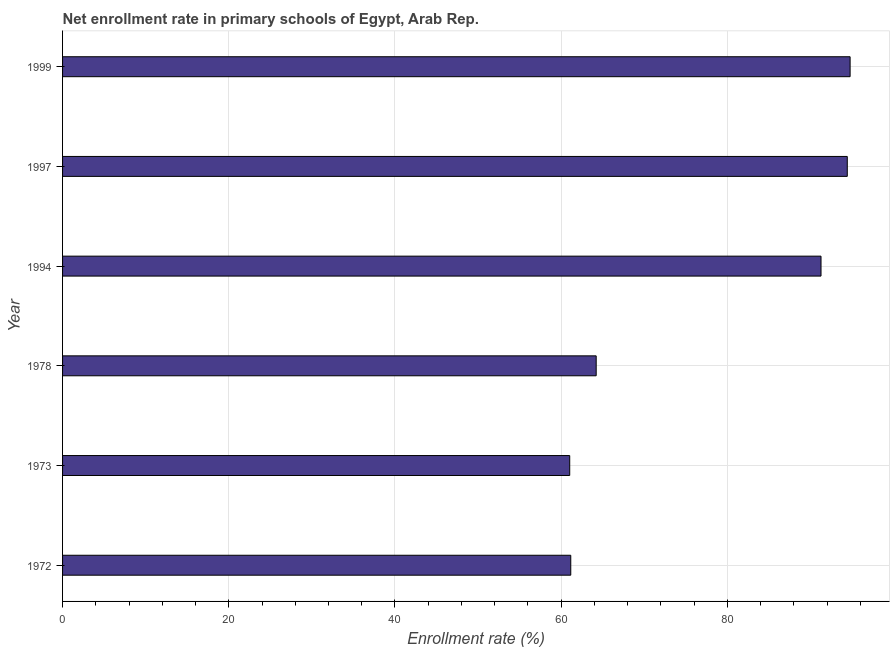Does the graph contain any zero values?
Provide a succinct answer. No. What is the title of the graph?
Give a very brief answer. Net enrollment rate in primary schools of Egypt, Arab Rep. What is the label or title of the X-axis?
Offer a terse response. Enrollment rate (%). What is the label or title of the Y-axis?
Your answer should be compact. Year. What is the net enrollment rate in primary schools in 1997?
Provide a short and direct response. 94.43. Across all years, what is the maximum net enrollment rate in primary schools?
Offer a terse response. 94.77. Across all years, what is the minimum net enrollment rate in primary schools?
Your answer should be very brief. 61.03. In which year was the net enrollment rate in primary schools maximum?
Provide a short and direct response. 1999. What is the sum of the net enrollment rate in primary schools?
Your answer should be compact. 466.87. What is the difference between the net enrollment rate in primary schools in 1978 and 1994?
Your answer should be compact. -27.06. What is the average net enrollment rate in primary schools per year?
Make the answer very short. 77.81. What is the median net enrollment rate in primary schools?
Your answer should be compact. 77.74. Do a majority of the years between 1999 and 1973 (inclusive) have net enrollment rate in primary schools greater than 40 %?
Make the answer very short. Yes. What is the ratio of the net enrollment rate in primary schools in 1978 to that in 1994?
Give a very brief answer. 0.7. Is the net enrollment rate in primary schools in 1973 less than that in 1997?
Provide a short and direct response. Yes. What is the difference between the highest and the second highest net enrollment rate in primary schools?
Provide a succinct answer. 0.34. What is the difference between the highest and the lowest net enrollment rate in primary schools?
Your answer should be very brief. 33.74. In how many years, is the net enrollment rate in primary schools greater than the average net enrollment rate in primary schools taken over all years?
Your answer should be very brief. 3. How many bars are there?
Provide a short and direct response. 6. Are all the bars in the graph horizontal?
Ensure brevity in your answer.  Yes. How many years are there in the graph?
Offer a very short reply. 6. What is the Enrollment rate (%) in 1972?
Provide a short and direct response. 61.16. What is the Enrollment rate (%) in 1973?
Your response must be concise. 61.03. What is the Enrollment rate (%) in 1978?
Give a very brief answer. 64.21. What is the Enrollment rate (%) of 1994?
Ensure brevity in your answer.  91.27. What is the Enrollment rate (%) of 1997?
Your answer should be compact. 94.43. What is the Enrollment rate (%) in 1999?
Provide a short and direct response. 94.77. What is the difference between the Enrollment rate (%) in 1972 and 1973?
Give a very brief answer. 0.13. What is the difference between the Enrollment rate (%) in 1972 and 1978?
Provide a succinct answer. -3.06. What is the difference between the Enrollment rate (%) in 1972 and 1994?
Your response must be concise. -30.12. What is the difference between the Enrollment rate (%) in 1972 and 1997?
Your answer should be compact. -33.27. What is the difference between the Enrollment rate (%) in 1972 and 1999?
Make the answer very short. -33.62. What is the difference between the Enrollment rate (%) in 1973 and 1978?
Your answer should be compact. -3.18. What is the difference between the Enrollment rate (%) in 1973 and 1994?
Give a very brief answer. -30.24. What is the difference between the Enrollment rate (%) in 1973 and 1997?
Your response must be concise. -33.4. What is the difference between the Enrollment rate (%) in 1973 and 1999?
Ensure brevity in your answer.  -33.74. What is the difference between the Enrollment rate (%) in 1978 and 1994?
Offer a terse response. -27.06. What is the difference between the Enrollment rate (%) in 1978 and 1997?
Keep it short and to the point. -30.22. What is the difference between the Enrollment rate (%) in 1978 and 1999?
Your answer should be compact. -30.56. What is the difference between the Enrollment rate (%) in 1994 and 1997?
Provide a succinct answer. -3.16. What is the difference between the Enrollment rate (%) in 1994 and 1999?
Offer a very short reply. -3.5. What is the difference between the Enrollment rate (%) in 1997 and 1999?
Make the answer very short. -0.34. What is the ratio of the Enrollment rate (%) in 1972 to that in 1973?
Provide a succinct answer. 1. What is the ratio of the Enrollment rate (%) in 1972 to that in 1994?
Provide a succinct answer. 0.67. What is the ratio of the Enrollment rate (%) in 1972 to that in 1997?
Offer a very short reply. 0.65. What is the ratio of the Enrollment rate (%) in 1972 to that in 1999?
Give a very brief answer. 0.65. What is the ratio of the Enrollment rate (%) in 1973 to that in 1978?
Offer a terse response. 0.95. What is the ratio of the Enrollment rate (%) in 1973 to that in 1994?
Offer a very short reply. 0.67. What is the ratio of the Enrollment rate (%) in 1973 to that in 1997?
Your answer should be compact. 0.65. What is the ratio of the Enrollment rate (%) in 1973 to that in 1999?
Offer a very short reply. 0.64. What is the ratio of the Enrollment rate (%) in 1978 to that in 1994?
Your response must be concise. 0.7. What is the ratio of the Enrollment rate (%) in 1978 to that in 1997?
Offer a terse response. 0.68. What is the ratio of the Enrollment rate (%) in 1978 to that in 1999?
Give a very brief answer. 0.68. What is the ratio of the Enrollment rate (%) in 1994 to that in 1997?
Keep it short and to the point. 0.97. What is the ratio of the Enrollment rate (%) in 1997 to that in 1999?
Your answer should be compact. 1. 